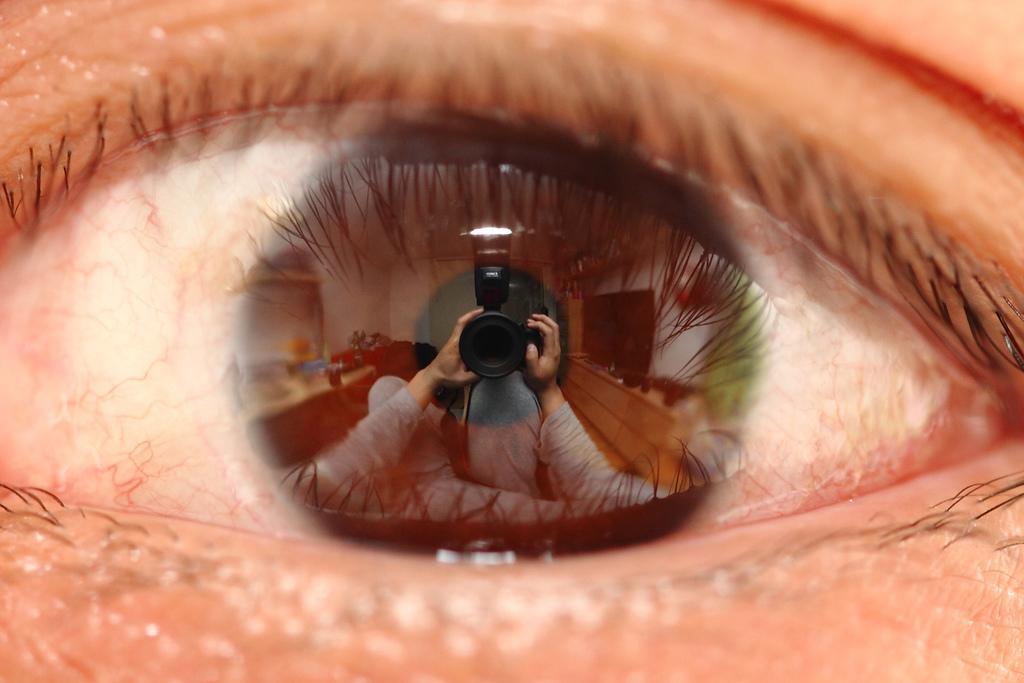Could you give a brief overview of what you see in this image? This is the image of an eye, there is a pupil in which we can see the reflection of a person holding camera, there is a television, there is a table with flower vase and other objects placed on the table. 